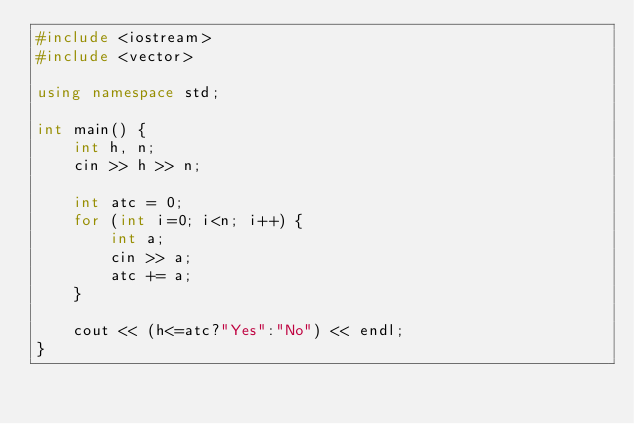<code> <loc_0><loc_0><loc_500><loc_500><_C++_>#include <iostream>
#include <vector>

using namespace std;

int main() {
    int h, n;
    cin >> h >> n;

    int atc = 0;
    for (int i=0; i<n; i++) {
        int a;
        cin >> a;
        atc += a;
    }

    cout << (h<=atc?"Yes":"No") << endl;
}
</code> 